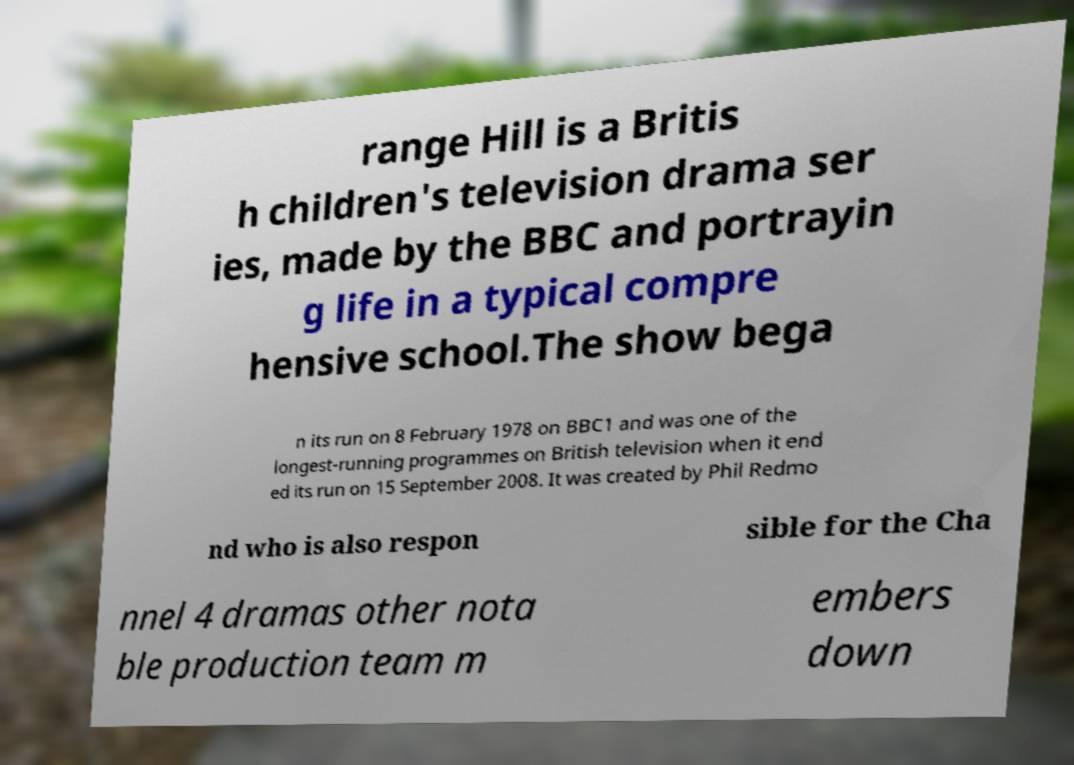For documentation purposes, I need the text within this image transcribed. Could you provide that? range Hill is a Britis h children's television drama ser ies, made by the BBC and portrayin g life in a typical compre hensive school.The show bega n its run on 8 February 1978 on BBC1 and was one of the longest-running programmes on British television when it end ed its run on 15 September 2008. It was created by Phil Redmo nd who is also respon sible for the Cha nnel 4 dramas other nota ble production team m embers down 